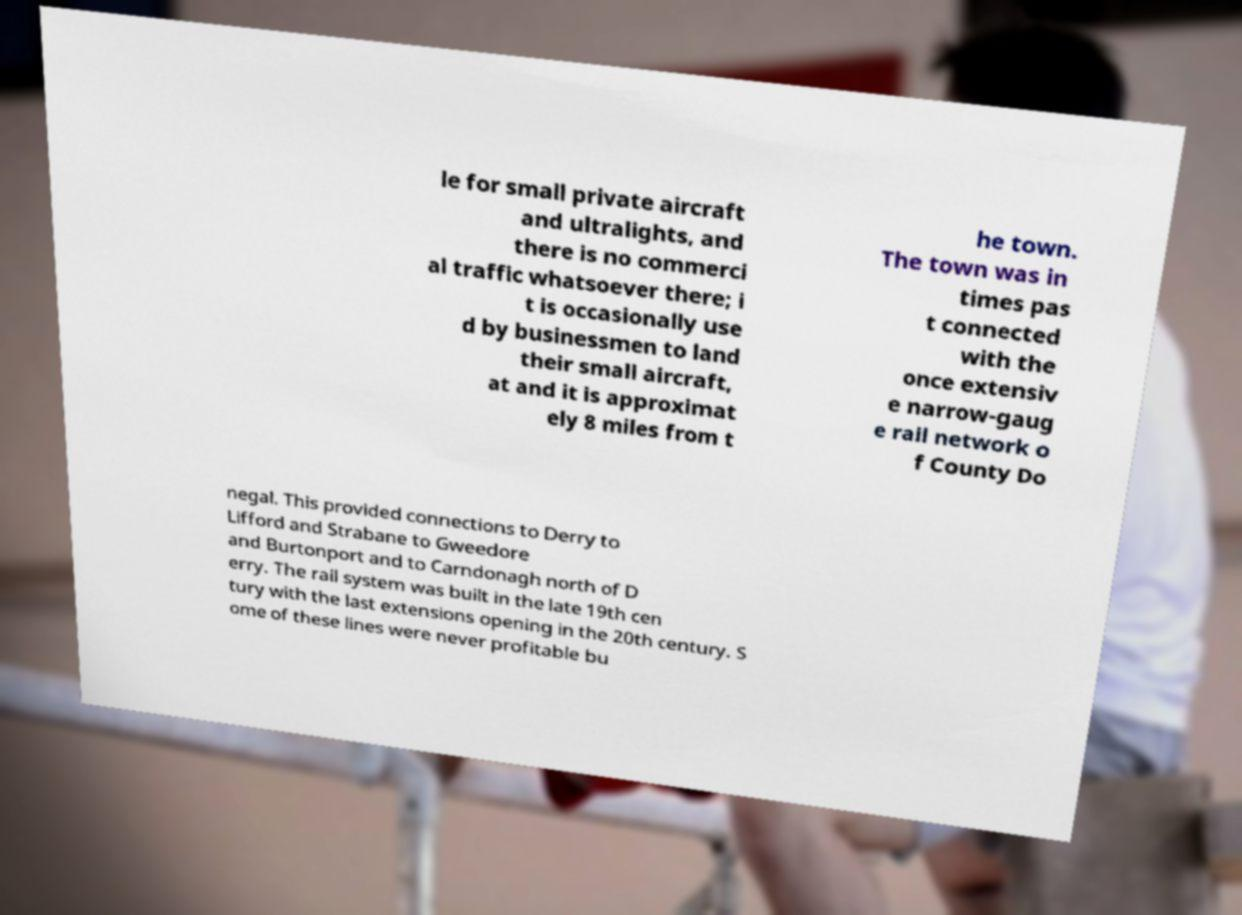Could you extract and type out the text from this image? le for small private aircraft and ultralights, and there is no commerci al traffic whatsoever there; i t is occasionally use d by businessmen to land their small aircraft, at and it is approximat ely 8 miles from t he town. The town was in times pas t connected with the once extensiv e narrow-gaug e rail network o f County Do negal. This provided connections to Derry to Lifford and Strabane to Gweedore and Burtonport and to Carndonagh north of D erry. The rail system was built in the late 19th cen tury with the last extensions opening in the 20th century. S ome of these lines were never profitable bu 